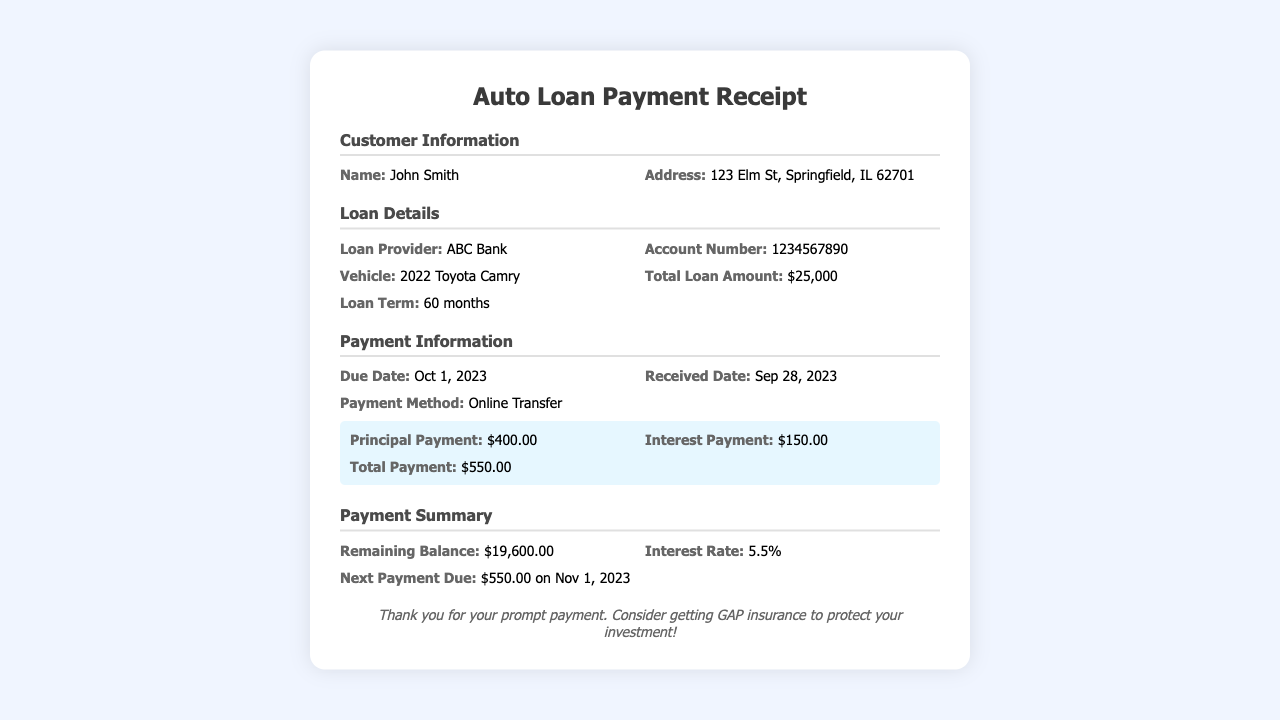what is the total loan amount? The total loan amount is stated under Loan Details as $25,000.
Answer: $25,000 who is the loan provider? The loan provider is mentioned in the Loan Details section, which is ABC Bank.
Answer: ABC Bank what is the interest payment? The interest payment is highlighted in the Payment Information section as $150.00.
Answer: $150.00 what is the next payment due date? The next payment due date is found in the Payment Summary as Nov 1, 2023.
Answer: Nov 1, 2023 how much is the remaining balance after this payment? The remaining balance is summarized in the Payment Summary as $19,600.00.
Answer: $19,600.00 what is the loan term duration? The loan term duration is listed under Loan Details as 60 months.
Answer: 60 months what was the payment method? The payment method used is specified in the Payment Information as Online Transfer.
Answer: Online Transfer what is the principal payment? The principal payment is indicated in the payment highlight as $400.00.
Answer: $400.00 why is GAP insurance suggested? The note at the bottom encourages GAP insurance to protect your investment after making the payment.
Answer: To protect your investment! 